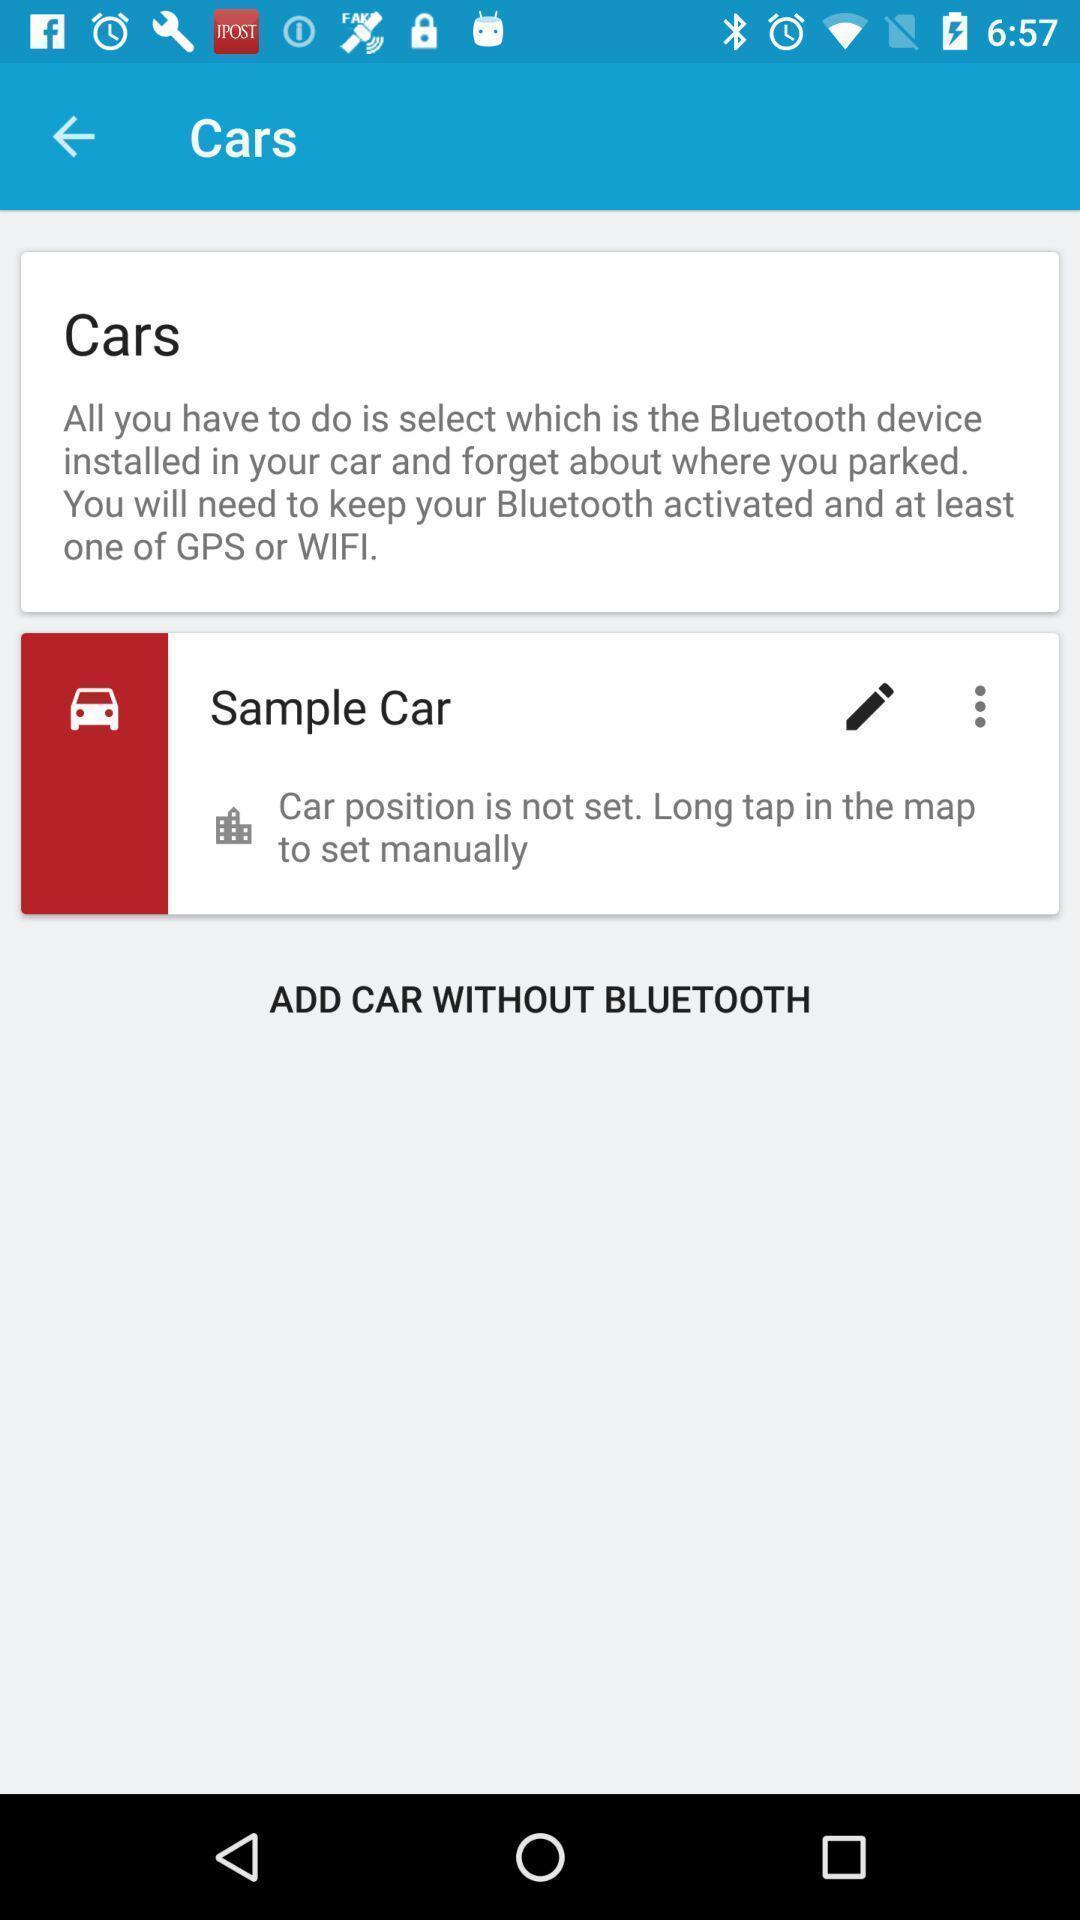What is the overall content of this screenshot? Page shows some information in a service application. 